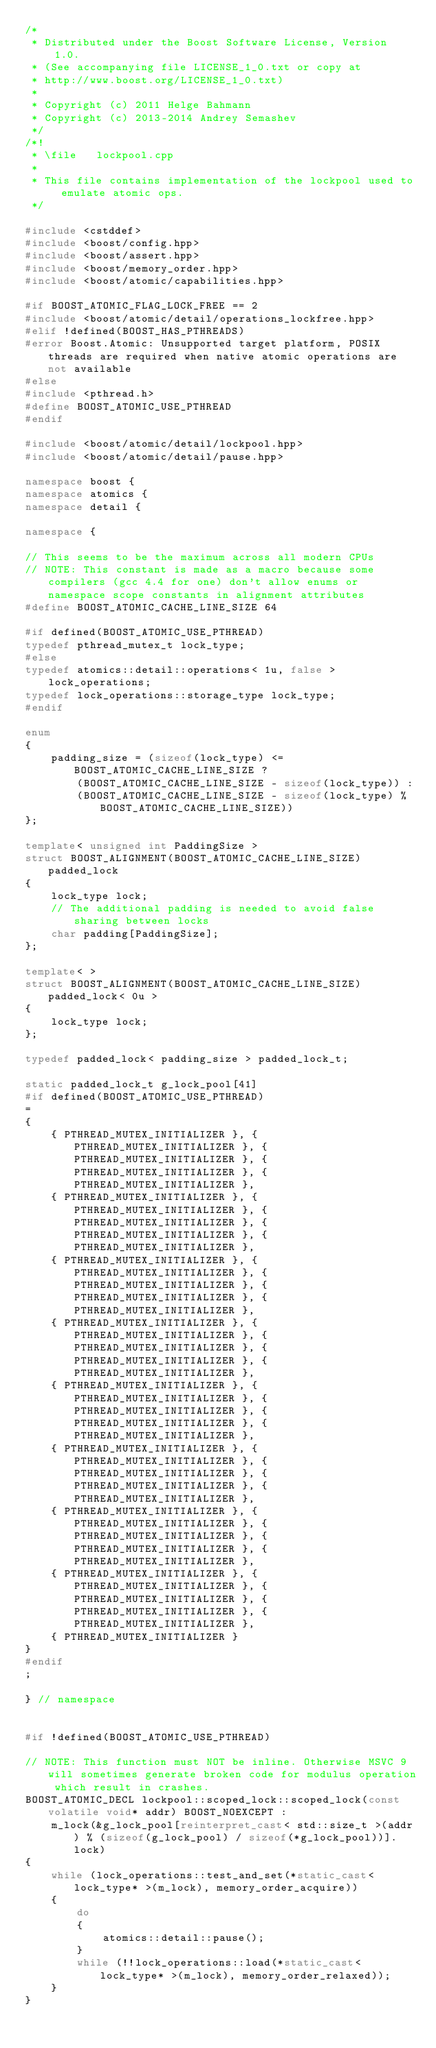Convert code to text. <code><loc_0><loc_0><loc_500><loc_500><_C++_>/*
 * Distributed under the Boost Software License, Version 1.0.
 * (See accompanying file LICENSE_1_0.txt or copy at
 * http://www.boost.org/LICENSE_1_0.txt)
 *
 * Copyright (c) 2011 Helge Bahmann
 * Copyright (c) 2013-2014 Andrey Semashev
 */
/*!
 * \file   lockpool.cpp
 *
 * This file contains implementation of the lockpool used to emulate atomic ops.
 */

#include <cstddef>
#include <boost/config.hpp>
#include <boost/assert.hpp>
#include <boost/memory_order.hpp>
#include <boost/atomic/capabilities.hpp>

#if BOOST_ATOMIC_FLAG_LOCK_FREE == 2
#include <boost/atomic/detail/operations_lockfree.hpp>
#elif !defined(BOOST_HAS_PTHREADS)
#error Boost.Atomic: Unsupported target platform, POSIX threads are required when native atomic operations are not available
#else
#include <pthread.h>
#define BOOST_ATOMIC_USE_PTHREAD
#endif

#include <boost/atomic/detail/lockpool.hpp>
#include <boost/atomic/detail/pause.hpp>

namespace boost {
namespace atomics {
namespace detail {

namespace {

// This seems to be the maximum across all modern CPUs
// NOTE: This constant is made as a macro because some compilers (gcc 4.4 for one) don't allow enums or namespace scope constants in alignment attributes
#define BOOST_ATOMIC_CACHE_LINE_SIZE 64

#if defined(BOOST_ATOMIC_USE_PTHREAD)
typedef pthread_mutex_t lock_type;
#else
typedef atomics::detail::operations< 1u, false > lock_operations;
typedef lock_operations::storage_type lock_type;
#endif

enum
{
    padding_size = (sizeof(lock_type) <= BOOST_ATOMIC_CACHE_LINE_SIZE ?
        (BOOST_ATOMIC_CACHE_LINE_SIZE - sizeof(lock_type)) :
        (BOOST_ATOMIC_CACHE_LINE_SIZE - sizeof(lock_type) % BOOST_ATOMIC_CACHE_LINE_SIZE))
};

template< unsigned int PaddingSize >
struct BOOST_ALIGNMENT(BOOST_ATOMIC_CACHE_LINE_SIZE) padded_lock
{
    lock_type lock;
    // The additional padding is needed to avoid false sharing between locks
    char padding[PaddingSize];
};

template< >
struct BOOST_ALIGNMENT(BOOST_ATOMIC_CACHE_LINE_SIZE) padded_lock< 0u >
{
    lock_type lock;
};

typedef padded_lock< padding_size > padded_lock_t;

static padded_lock_t g_lock_pool[41]
#if defined(BOOST_ATOMIC_USE_PTHREAD)
=
{
    { PTHREAD_MUTEX_INITIALIZER }, { PTHREAD_MUTEX_INITIALIZER }, { PTHREAD_MUTEX_INITIALIZER }, { PTHREAD_MUTEX_INITIALIZER }, { PTHREAD_MUTEX_INITIALIZER },
    { PTHREAD_MUTEX_INITIALIZER }, { PTHREAD_MUTEX_INITIALIZER }, { PTHREAD_MUTEX_INITIALIZER }, { PTHREAD_MUTEX_INITIALIZER }, { PTHREAD_MUTEX_INITIALIZER },
    { PTHREAD_MUTEX_INITIALIZER }, { PTHREAD_MUTEX_INITIALIZER }, { PTHREAD_MUTEX_INITIALIZER }, { PTHREAD_MUTEX_INITIALIZER }, { PTHREAD_MUTEX_INITIALIZER },
    { PTHREAD_MUTEX_INITIALIZER }, { PTHREAD_MUTEX_INITIALIZER }, { PTHREAD_MUTEX_INITIALIZER }, { PTHREAD_MUTEX_INITIALIZER }, { PTHREAD_MUTEX_INITIALIZER },
    { PTHREAD_MUTEX_INITIALIZER }, { PTHREAD_MUTEX_INITIALIZER }, { PTHREAD_MUTEX_INITIALIZER }, { PTHREAD_MUTEX_INITIALIZER }, { PTHREAD_MUTEX_INITIALIZER },
    { PTHREAD_MUTEX_INITIALIZER }, { PTHREAD_MUTEX_INITIALIZER }, { PTHREAD_MUTEX_INITIALIZER }, { PTHREAD_MUTEX_INITIALIZER }, { PTHREAD_MUTEX_INITIALIZER },
    { PTHREAD_MUTEX_INITIALIZER }, { PTHREAD_MUTEX_INITIALIZER }, { PTHREAD_MUTEX_INITIALIZER }, { PTHREAD_MUTEX_INITIALIZER }, { PTHREAD_MUTEX_INITIALIZER },
    { PTHREAD_MUTEX_INITIALIZER }, { PTHREAD_MUTEX_INITIALIZER }, { PTHREAD_MUTEX_INITIALIZER }, { PTHREAD_MUTEX_INITIALIZER }, { PTHREAD_MUTEX_INITIALIZER },
    { PTHREAD_MUTEX_INITIALIZER }
}
#endif
;

} // namespace


#if !defined(BOOST_ATOMIC_USE_PTHREAD)

// NOTE: This function must NOT be inline. Otherwise MSVC 9 will sometimes generate broken code for modulus operation which result in crashes.
BOOST_ATOMIC_DECL lockpool::scoped_lock::scoped_lock(const volatile void* addr) BOOST_NOEXCEPT :
    m_lock(&g_lock_pool[reinterpret_cast< std::size_t >(addr) % (sizeof(g_lock_pool) / sizeof(*g_lock_pool))].lock)
{
    while (lock_operations::test_and_set(*static_cast< lock_type* >(m_lock), memory_order_acquire))
    {
        do
        {
            atomics::detail::pause();
        }
        while (!!lock_operations::load(*static_cast< lock_type* >(m_lock), memory_order_relaxed));
    }
}
</code> 